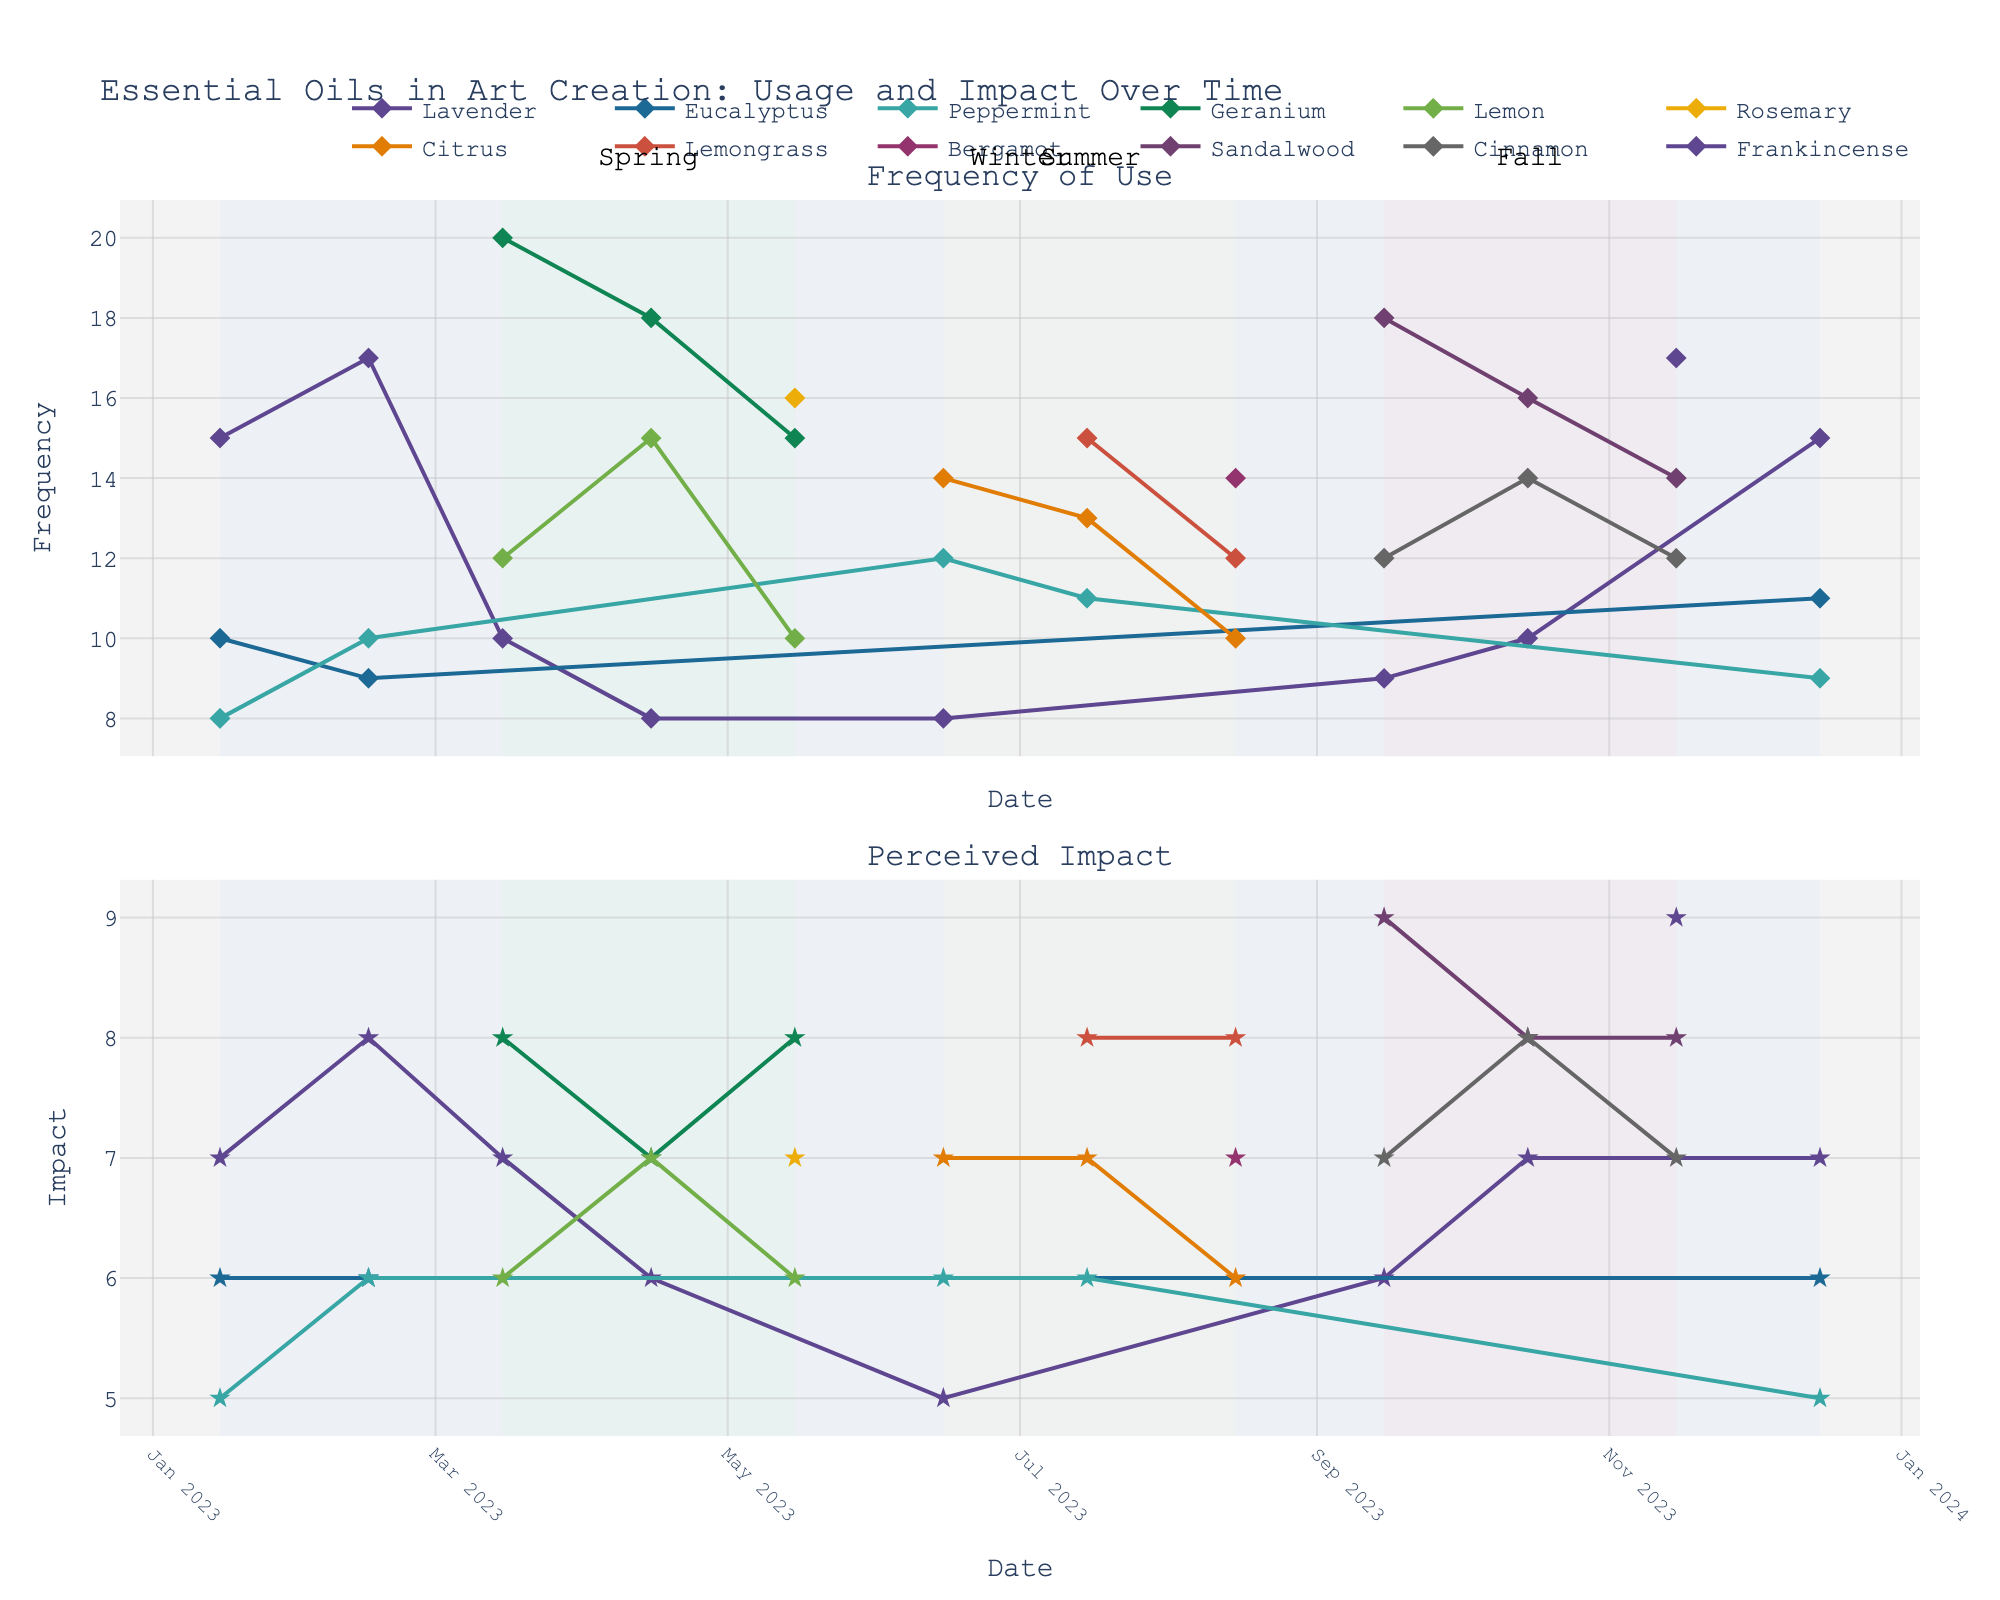What is the title of the figure? The title of the figure is displayed at the top, summarizing the content of the plot. It helps in understanding what the data is illustrating.
Answer: Essential Oils in Art Creation: Usage and Impact Over Time How many essential oils are tracked in the figure? By counting the different lines or legends in the plot, each representing a unique essential oil, we can determine the number of essential oils tracked.
Answer: 13 Which season shows the highest perceived impact for Lavender? By examining the lower subplot for perceived impact and locating the points for Lavender across different seasons (annotated as background colors), we can identify the highest value.
Answer: Winter How does the frequency of use for Sandalwood change from September to November? By identifying the line corresponding to Sandalwood in the frequency of use plot and tracking its changes from September to November data points, we can observe any increases or decreases.
Answer: Decreases from 18 to 17 Which essential oil has the most consistent perceived impact across seasons? By comparing the variations in perceived impact (lower subplot) across seasons, we can determine which essential oil has the least fluctuation in its values.
Answer: Eucalyptus In which season is the frequency of use for Geranium the highest? By checking the frequency of use subplot and identifying the points for Geranium, we can see which season has the highest frequency.
Answer: Spring What is the average perceived impact for Peppermint in Winter and Summer? Calculate the average perceived impact for Peppermint by adding the values for Winter and Summer and dividing by the number of data points.
Answer: (5+6+5+6)/4 = 5.5 Which essential oil shows a peak in frequency of use during Summer? By examining the frequency of use subplot and identifying peaks corresponding to the Summer season (yellow background), we can identify the essential oil.
Answer: Lemongrass Compare the frequency of use of Lavender in Winter and Fall. Which season has a higher frequency of use? By identifying the points for Lavender in the frequency of use subplot across Winter and Fall seasons, we can compare their values.
Answer: Winter What trend do you observe in the perceived impact of Citrus from June to August? By observing the pattern in the perceived impact subplot for Citrus over the months of June, July, and August, we can determine if the trend is increasing, decreasing, or stable.
Answer: Decreasing 